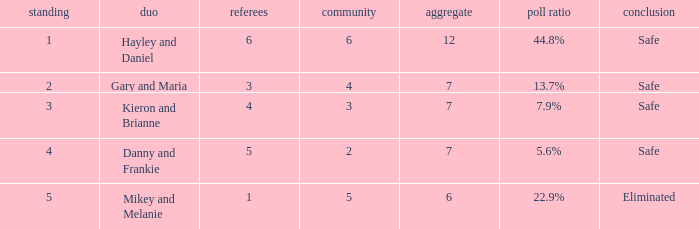How many judges were there for the eliminated couple?  1.0. 